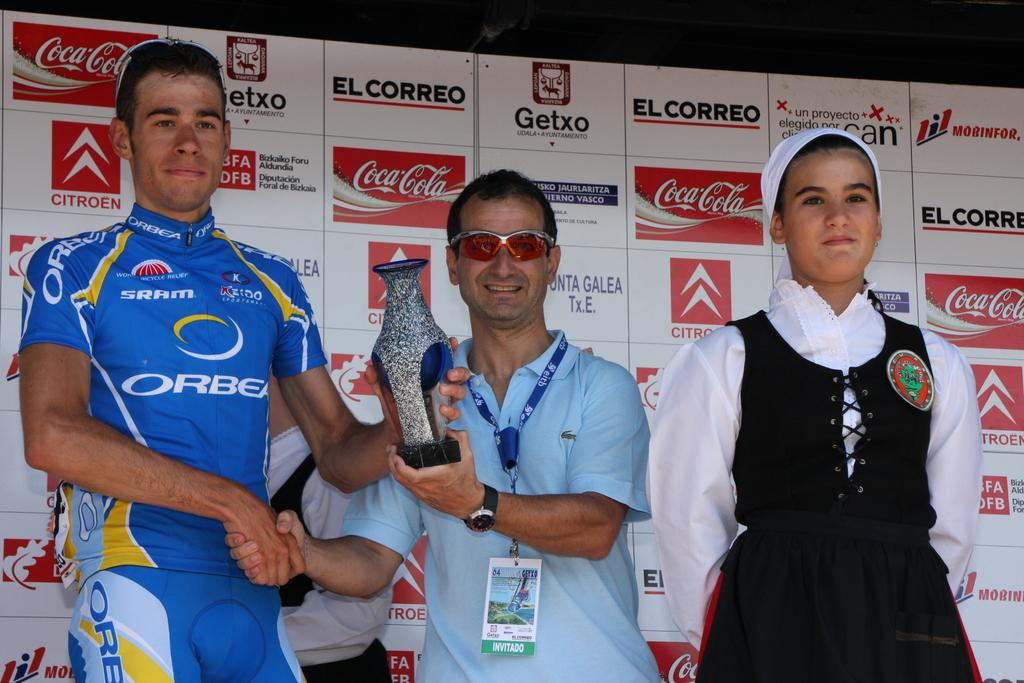<image>
Write a terse but informative summary of the picture. Three people are posed in front of signs that say Coca-Cola and El Correo. 